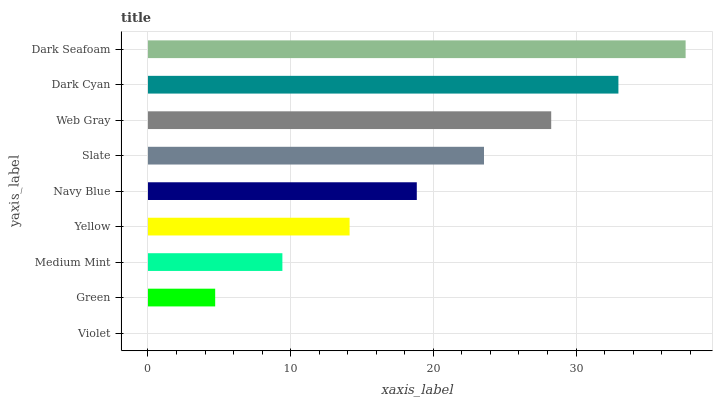Is Violet the minimum?
Answer yes or no. Yes. Is Dark Seafoam the maximum?
Answer yes or no. Yes. Is Green the minimum?
Answer yes or no. No. Is Green the maximum?
Answer yes or no. No. Is Green greater than Violet?
Answer yes or no. Yes. Is Violet less than Green?
Answer yes or no. Yes. Is Violet greater than Green?
Answer yes or no. No. Is Green less than Violet?
Answer yes or no. No. Is Navy Blue the high median?
Answer yes or no. Yes. Is Navy Blue the low median?
Answer yes or no. Yes. Is Green the high median?
Answer yes or no. No. Is Violet the low median?
Answer yes or no. No. 